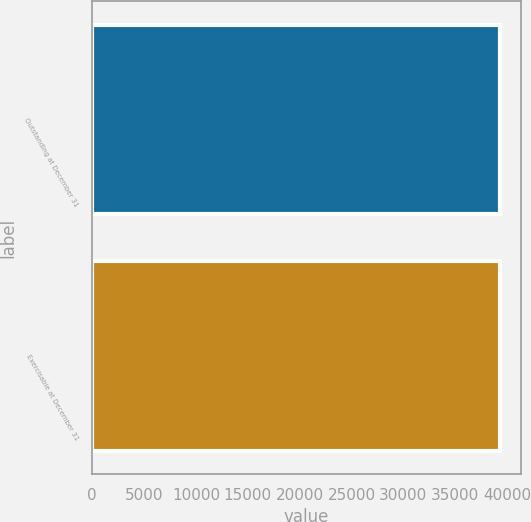Convert chart to OTSL. <chart><loc_0><loc_0><loc_500><loc_500><bar_chart><fcel>Outstanding at December 31<fcel>Exercisable at December 31<nl><fcel>39326<fcel>39305<nl></chart> 